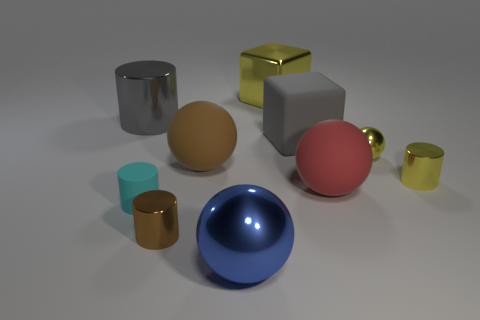Subtract all yellow spheres. How many spheres are left? 3 Subtract all yellow spheres. How many spheres are left? 3 Subtract all spheres. How many objects are left? 6 Subtract 3 cylinders. How many cylinders are left? 1 Subtract 1 brown balls. How many objects are left? 9 Subtract all cyan cylinders. Subtract all purple cubes. How many cylinders are left? 3 Subtract all green cylinders. How many gray cubes are left? 1 Subtract all purple cylinders. Subtract all big metal things. How many objects are left? 7 Add 5 yellow spheres. How many yellow spheres are left? 6 Add 6 brown rubber balls. How many brown rubber balls exist? 7 